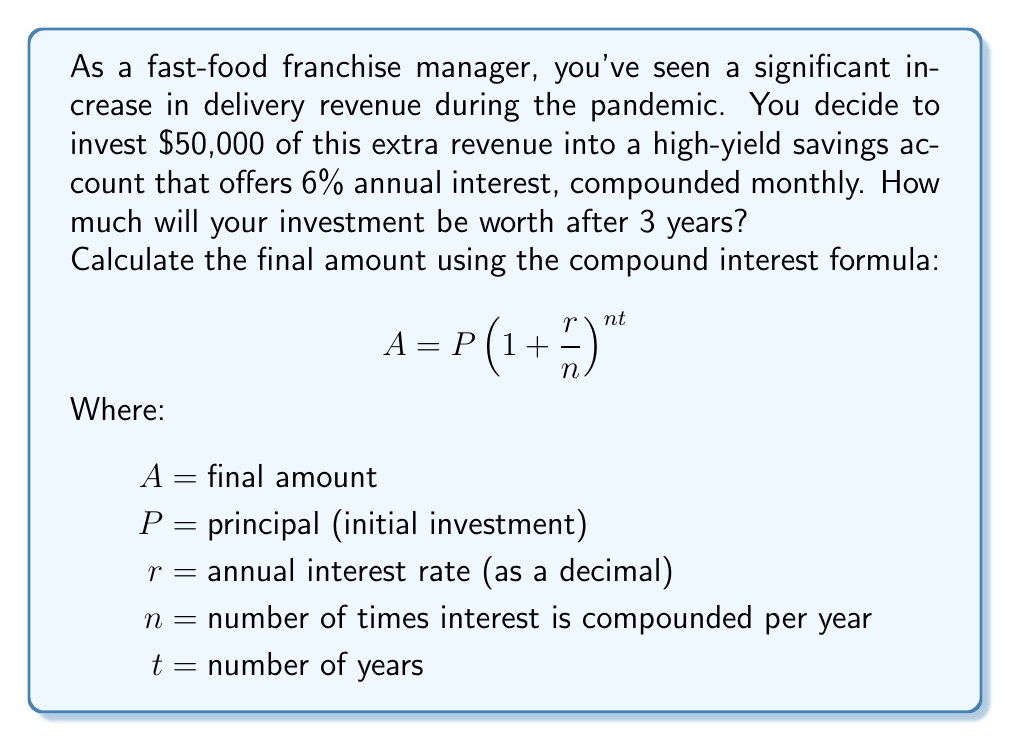Can you answer this question? Let's break down the problem and solve it step-by-step:

1. Identify the given values:
   $P = \$50,000$ (initial investment)
   $r = 0.06$ (6% annual interest rate as a decimal)
   $n = 12$ (compounded monthly, so 12 times per year)
   $t = 3$ years

2. Substitute these values into the compound interest formula:

   $$A = 50000(1 + \frac{0.06}{12})^{12 \times 3}$$

3. Simplify the expression inside the parentheses:

   $$A = 50000(1 + 0.005)^{36}$$

4. Calculate the value of $(1.005)^{36}$:
   $(1.005)^{36} \approx 1.1972$

5. Multiply the result by the initial investment:

   $$A = 50000 \times 1.1972 = 59,860$$

Therefore, after 3 years, the investment will be worth approximately $59,860.
Answer: $59,860 